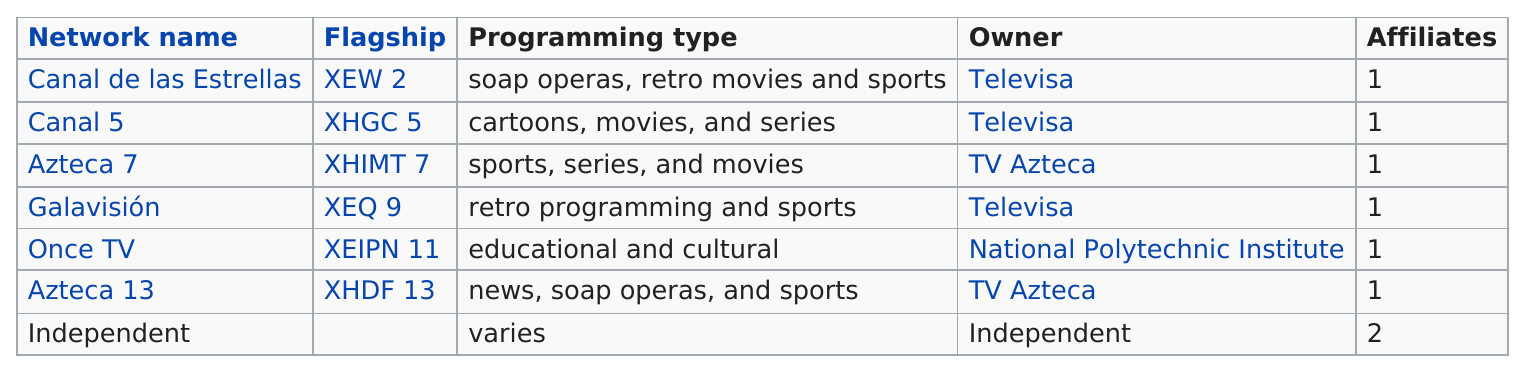Mention a couple of crucial points in this snapshot. TV Azteca owns 2 networks. Televisa owns three networks. There are two networks that do not air sports programming. The National Polytechnic Institute is the only network that owns Once TV. The average number of affiliates that a given affiliate network will have is 1.. 